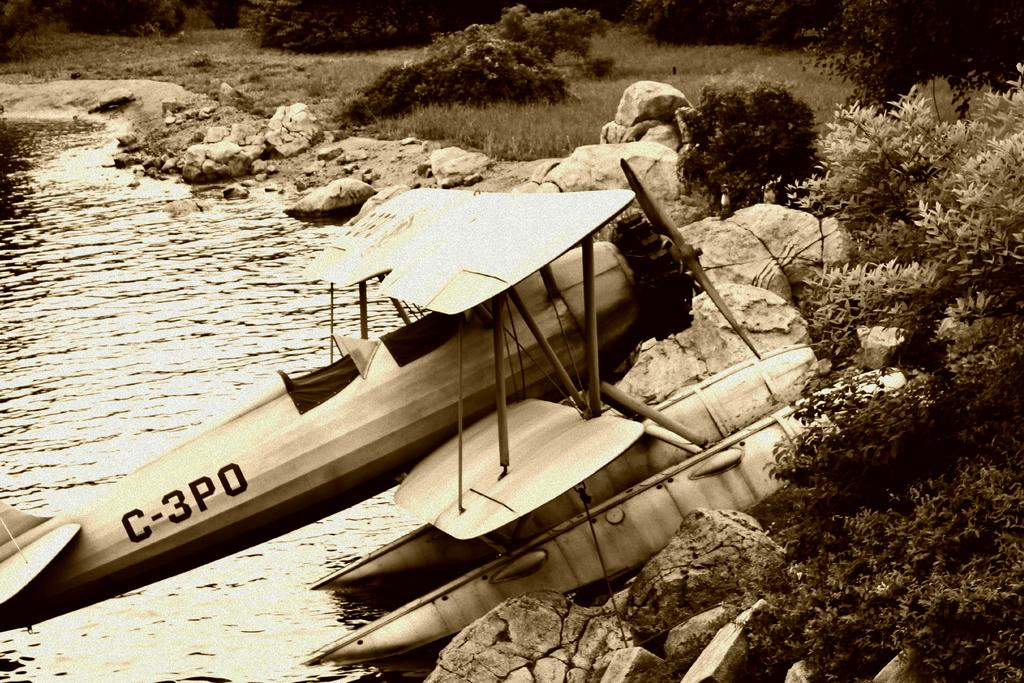What is the main subject of the picture? The main subject of the picture is an aircraft. What can be seen in the background of the image? Water, rocks, plants, and grass are visible in the picture. Are there any leaves visible in the image? Yes, leaves are visible in the picture. What is the purpose of the bomb in the image? There is no bomb present in the image. 